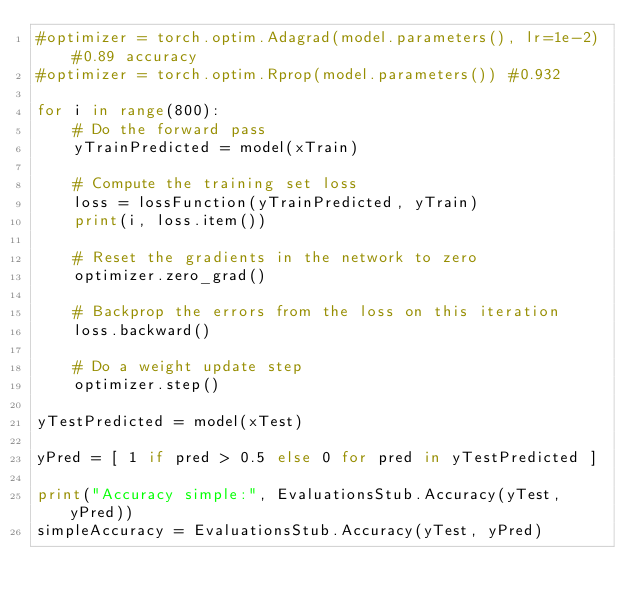<code> <loc_0><loc_0><loc_500><loc_500><_Python_>#optimizer = torch.optim.Adagrad(model.parameters(), lr=1e-2) #0.89 accuracy
#optimizer = torch.optim.Rprop(model.parameters()) #0.932

for i in range(800):
    # Do the forward pass
    yTrainPredicted = model(xTrain)

    # Compute the training set loss
    loss = lossFunction(yTrainPredicted, yTrain)
    print(i, loss.item())
    
    # Reset the gradients in the network to zero
    optimizer.zero_grad()

    # Backprop the errors from the loss on this iteration
    loss.backward()

    # Do a weight update step
    optimizer.step()

yTestPredicted = model(xTest)

yPred = [ 1 if pred > 0.5 else 0 for pred in yTestPredicted ]

print("Accuracy simple:", EvaluationsStub.Accuracy(yTest, yPred))
simpleAccuracy = EvaluationsStub.Accuracy(yTest, yPred)

</code> 